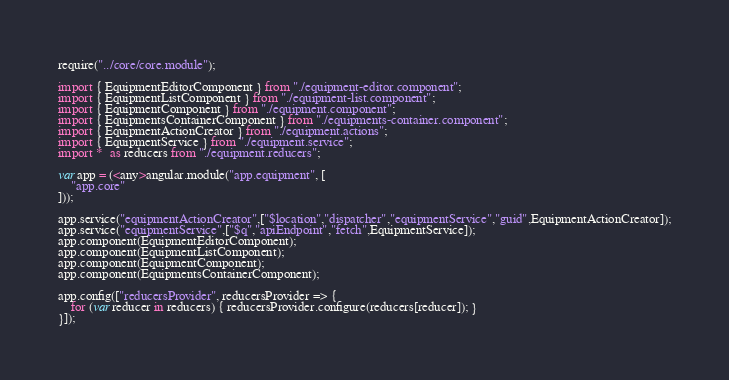<code> <loc_0><loc_0><loc_500><loc_500><_TypeScript_>require("../core/core.module");

import { EquipmentEditorComponent } from "./equipment-editor.component";
import { EquipmentListComponent } from "./equipment-list.component";
import { EquipmentComponent } from "./equipment.component";
import { EquipmentsContainerComponent } from "./equipments-container.component";
import { EquipmentActionCreator } from "./equipment.actions";
import { EquipmentService } from "./equipment.service";
import *  as reducers from "./equipment.reducers";

var app = (<any>angular.module("app.equipment", [
    "app.core"    
]));

app.service("equipmentActionCreator",["$location","dispatcher","equipmentService","guid",EquipmentActionCreator]);
app.service("equipmentService",["$q","apiEndpoint","fetch",EquipmentService]);
app.component(EquipmentEditorComponent);
app.component(EquipmentListComponent);
app.component(EquipmentComponent);
app.component(EquipmentsContainerComponent);

app.config(["reducersProvider", reducersProvider => {	
    for (var reducer in reducers) { reducersProvider.configure(reducers[reducer]); }
}]);
</code> 